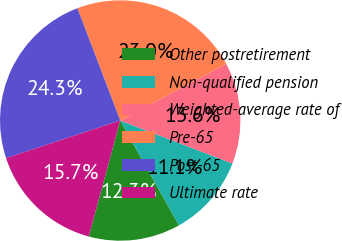Convert chart to OTSL. <chart><loc_0><loc_0><loc_500><loc_500><pie_chart><fcel>Other postretirement<fcel>Non-qualified pension<fcel>Weighted-average rate of<fcel>Pre-65<fcel>Post-65<fcel>Ultimate rate<nl><fcel>12.34%<fcel>11.05%<fcel>13.63%<fcel>22.99%<fcel>24.28%<fcel>15.71%<nl></chart> 